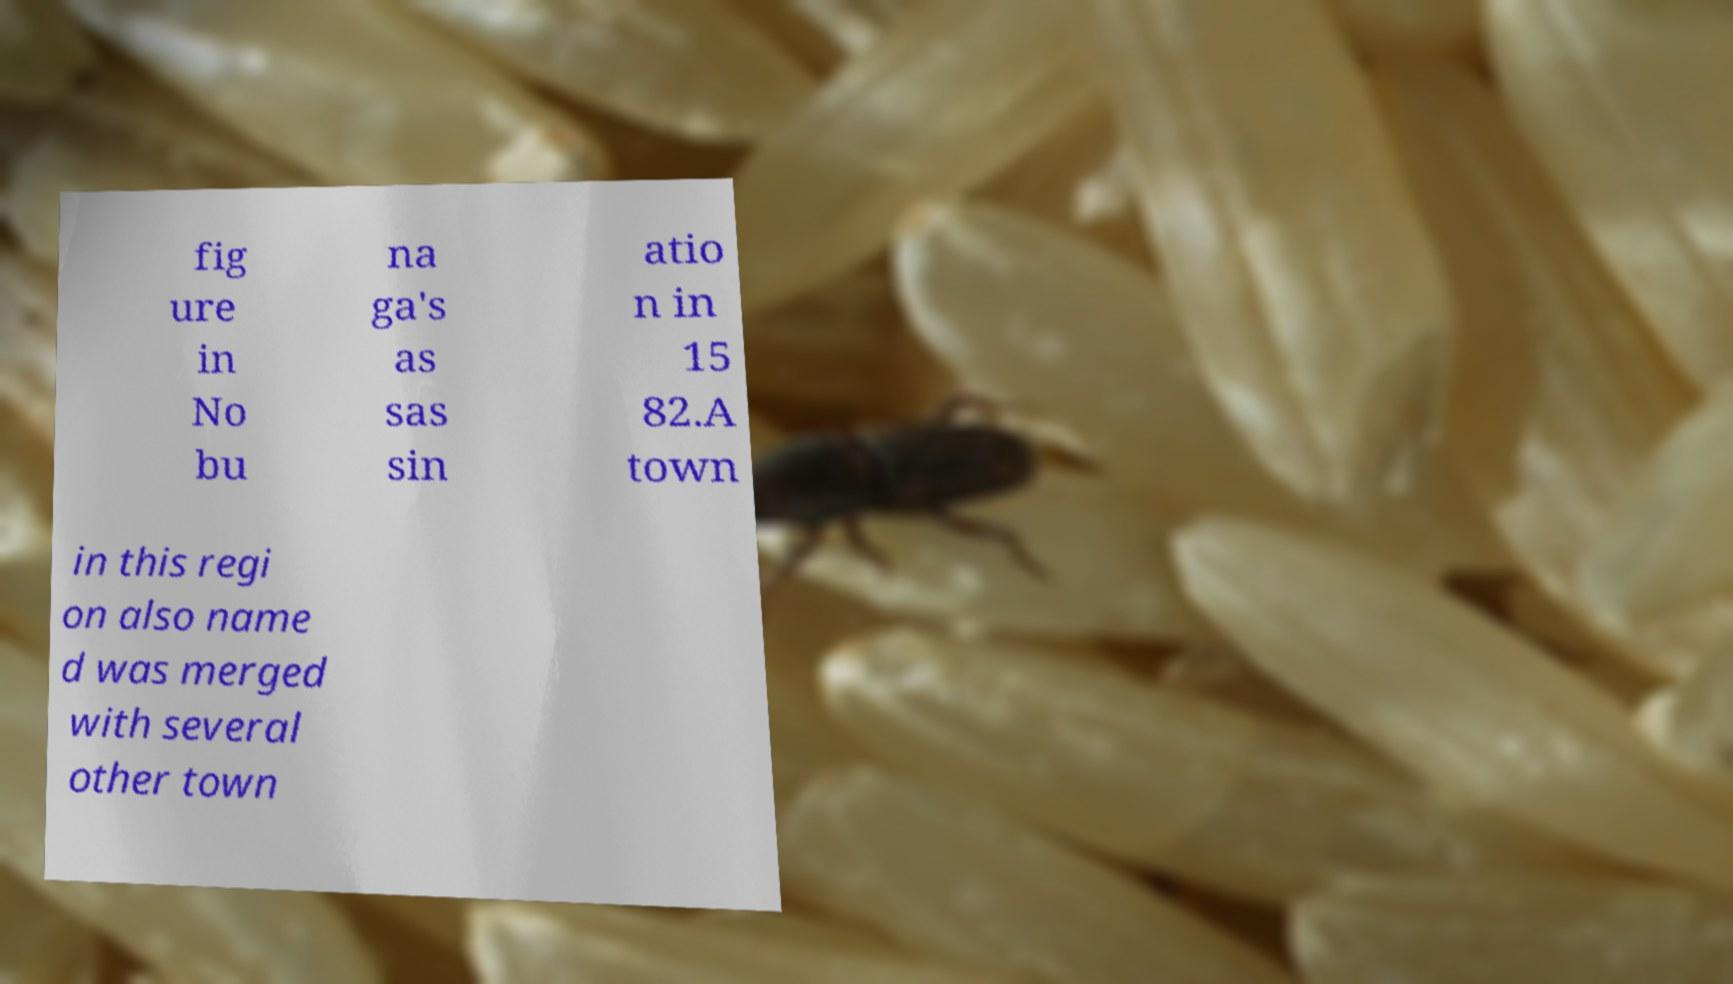Can you accurately transcribe the text from the provided image for me? fig ure in No bu na ga's as sas sin atio n in 15 82.A town in this regi on also name d was merged with several other town 